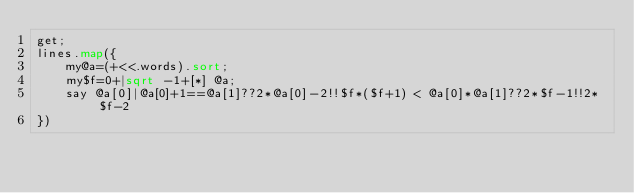Convert code to text. <code><loc_0><loc_0><loc_500><loc_500><_Perl_>get;
lines.map({
	my@a=(+<<.words).sort;
	my$f=0+|sqrt -1+[*] @a;
	say @a[0]|@a[0]+1==@a[1]??2*@a[0]-2!!$f*($f+1) < @a[0]*@a[1]??2*$f-1!!2*$f-2
})</code> 